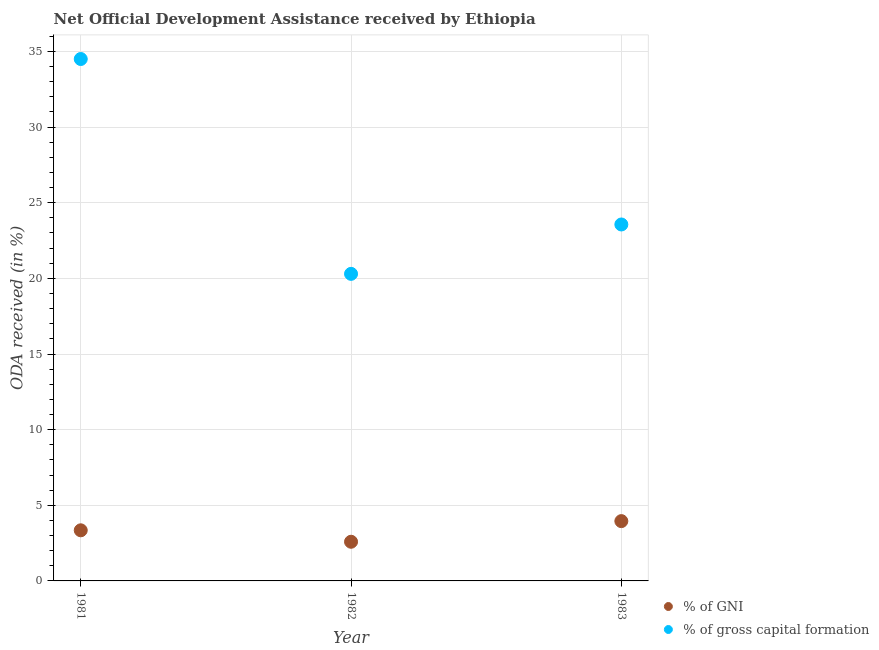Is the number of dotlines equal to the number of legend labels?
Offer a terse response. Yes. What is the oda received as percentage of gross capital formation in 1983?
Keep it short and to the point. 23.56. Across all years, what is the maximum oda received as percentage of gni?
Offer a very short reply. 3.95. Across all years, what is the minimum oda received as percentage of gni?
Provide a short and direct response. 2.59. What is the total oda received as percentage of gross capital formation in the graph?
Make the answer very short. 78.36. What is the difference between the oda received as percentage of gross capital formation in 1981 and that in 1982?
Provide a short and direct response. 14.2. What is the difference between the oda received as percentage of gross capital formation in 1981 and the oda received as percentage of gni in 1983?
Ensure brevity in your answer.  30.55. What is the average oda received as percentage of gni per year?
Your answer should be very brief. 3.3. In the year 1982, what is the difference between the oda received as percentage of gni and oda received as percentage of gross capital formation?
Your response must be concise. -17.71. What is the ratio of the oda received as percentage of gross capital formation in 1982 to that in 1983?
Your response must be concise. 0.86. Is the difference between the oda received as percentage of gni in 1981 and 1982 greater than the difference between the oda received as percentage of gross capital formation in 1981 and 1982?
Provide a short and direct response. No. What is the difference between the highest and the second highest oda received as percentage of gni?
Your answer should be very brief. 0.61. What is the difference between the highest and the lowest oda received as percentage of gni?
Provide a succinct answer. 1.36. Is the sum of the oda received as percentage of gross capital formation in 1981 and 1983 greater than the maximum oda received as percentage of gni across all years?
Your answer should be very brief. Yes. Does the oda received as percentage of gross capital formation monotonically increase over the years?
Keep it short and to the point. No. What is the difference between two consecutive major ticks on the Y-axis?
Ensure brevity in your answer.  5. Does the graph contain grids?
Ensure brevity in your answer.  Yes. How are the legend labels stacked?
Your response must be concise. Vertical. What is the title of the graph?
Your response must be concise. Net Official Development Assistance received by Ethiopia. What is the label or title of the Y-axis?
Keep it short and to the point. ODA received (in %). What is the ODA received (in %) of % of GNI in 1981?
Your response must be concise. 3.35. What is the ODA received (in %) of % of gross capital formation in 1981?
Provide a succinct answer. 34.5. What is the ODA received (in %) in % of GNI in 1982?
Keep it short and to the point. 2.59. What is the ODA received (in %) of % of gross capital formation in 1982?
Make the answer very short. 20.3. What is the ODA received (in %) in % of GNI in 1983?
Offer a terse response. 3.95. What is the ODA received (in %) of % of gross capital formation in 1983?
Provide a succinct answer. 23.56. Across all years, what is the maximum ODA received (in %) in % of GNI?
Offer a very short reply. 3.95. Across all years, what is the maximum ODA received (in %) in % of gross capital formation?
Your answer should be compact. 34.5. Across all years, what is the minimum ODA received (in %) of % of GNI?
Provide a succinct answer. 2.59. Across all years, what is the minimum ODA received (in %) of % of gross capital formation?
Provide a succinct answer. 20.3. What is the total ODA received (in %) of % of GNI in the graph?
Your answer should be compact. 9.89. What is the total ODA received (in %) in % of gross capital formation in the graph?
Offer a terse response. 78.36. What is the difference between the ODA received (in %) of % of GNI in 1981 and that in 1982?
Your answer should be very brief. 0.76. What is the difference between the ODA received (in %) in % of gross capital formation in 1981 and that in 1982?
Offer a very short reply. 14.2. What is the difference between the ODA received (in %) in % of GNI in 1981 and that in 1983?
Your answer should be very brief. -0.61. What is the difference between the ODA received (in %) in % of gross capital formation in 1981 and that in 1983?
Your answer should be very brief. 10.94. What is the difference between the ODA received (in %) of % of GNI in 1982 and that in 1983?
Ensure brevity in your answer.  -1.36. What is the difference between the ODA received (in %) of % of gross capital formation in 1982 and that in 1983?
Your response must be concise. -3.26. What is the difference between the ODA received (in %) of % of GNI in 1981 and the ODA received (in %) of % of gross capital formation in 1982?
Make the answer very short. -16.95. What is the difference between the ODA received (in %) of % of GNI in 1981 and the ODA received (in %) of % of gross capital formation in 1983?
Offer a very short reply. -20.22. What is the difference between the ODA received (in %) in % of GNI in 1982 and the ODA received (in %) in % of gross capital formation in 1983?
Provide a succinct answer. -20.97. What is the average ODA received (in %) in % of GNI per year?
Your response must be concise. 3.3. What is the average ODA received (in %) of % of gross capital formation per year?
Make the answer very short. 26.12. In the year 1981, what is the difference between the ODA received (in %) in % of GNI and ODA received (in %) in % of gross capital formation?
Offer a very short reply. -31.15. In the year 1982, what is the difference between the ODA received (in %) of % of GNI and ODA received (in %) of % of gross capital formation?
Give a very brief answer. -17.71. In the year 1983, what is the difference between the ODA received (in %) of % of GNI and ODA received (in %) of % of gross capital formation?
Offer a very short reply. -19.61. What is the ratio of the ODA received (in %) of % of GNI in 1981 to that in 1982?
Provide a short and direct response. 1.29. What is the ratio of the ODA received (in %) in % of gross capital formation in 1981 to that in 1982?
Ensure brevity in your answer.  1.7. What is the ratio of the ODA received (in %) in % of GNI in 1981 to that in 1983?
Give a very brief answer. 0.85. What is the ratio of the ODA received (in %) of % of gross capital formation in 1981 to that in 1983?
Provide a succinct answer. 1.46. What is the ratio of the ODA received (in %) in % of GNI in 1982 to that in 1983?
Make the answer very short. 0.66. What is the ratio of the ODA received (in %) in % of gross capital formation in 1982 to that in 1983?
Give a very brief answer. 0.86. What is the difference between the highest and the second highest ODA received (in %) of % of GNI?
Offer a very short reply. 0.61. What is the difference between the highest and the second highest ODA received (in %) in % of gross capital formation?
Ensure brevity in your answer.  10.94. What is the difference between the highest and the lowest ODA received (in %) in % of GNI?
Make the answer very short. 1.36. What is the difference between the highest and the lowest ODA received (in %) of % of gross capital formation?
Keep it short and to the point. 14.2. 